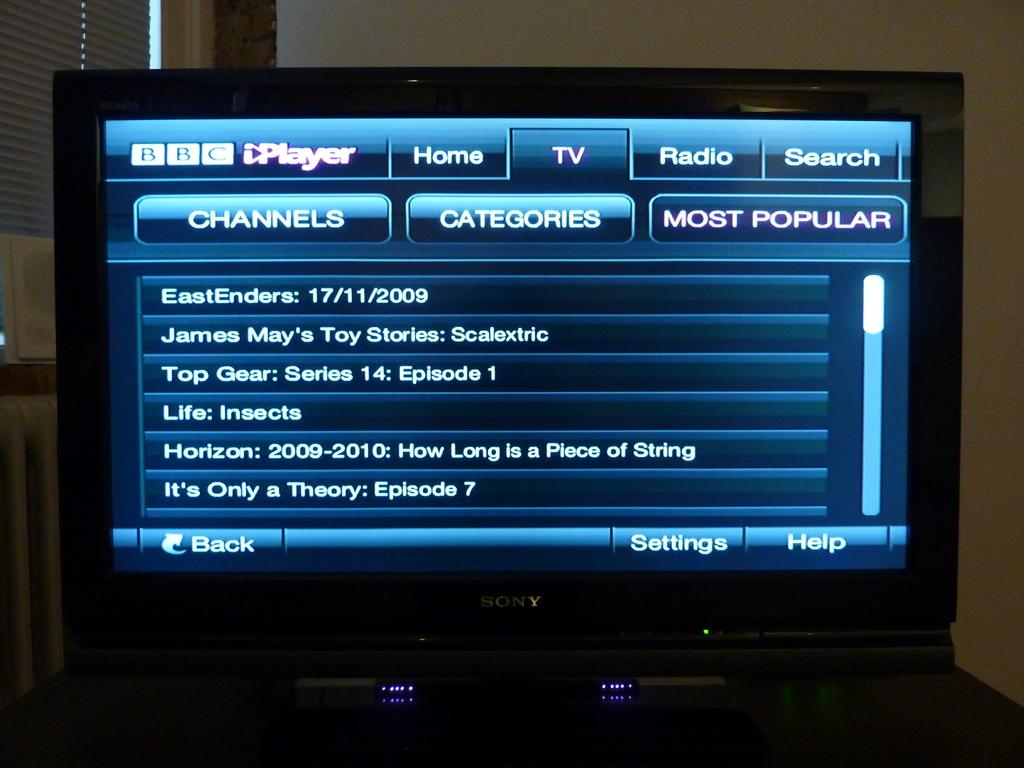Provide a one-sentence caption for the provided image. BBC channel is on top right corner of the screen. 